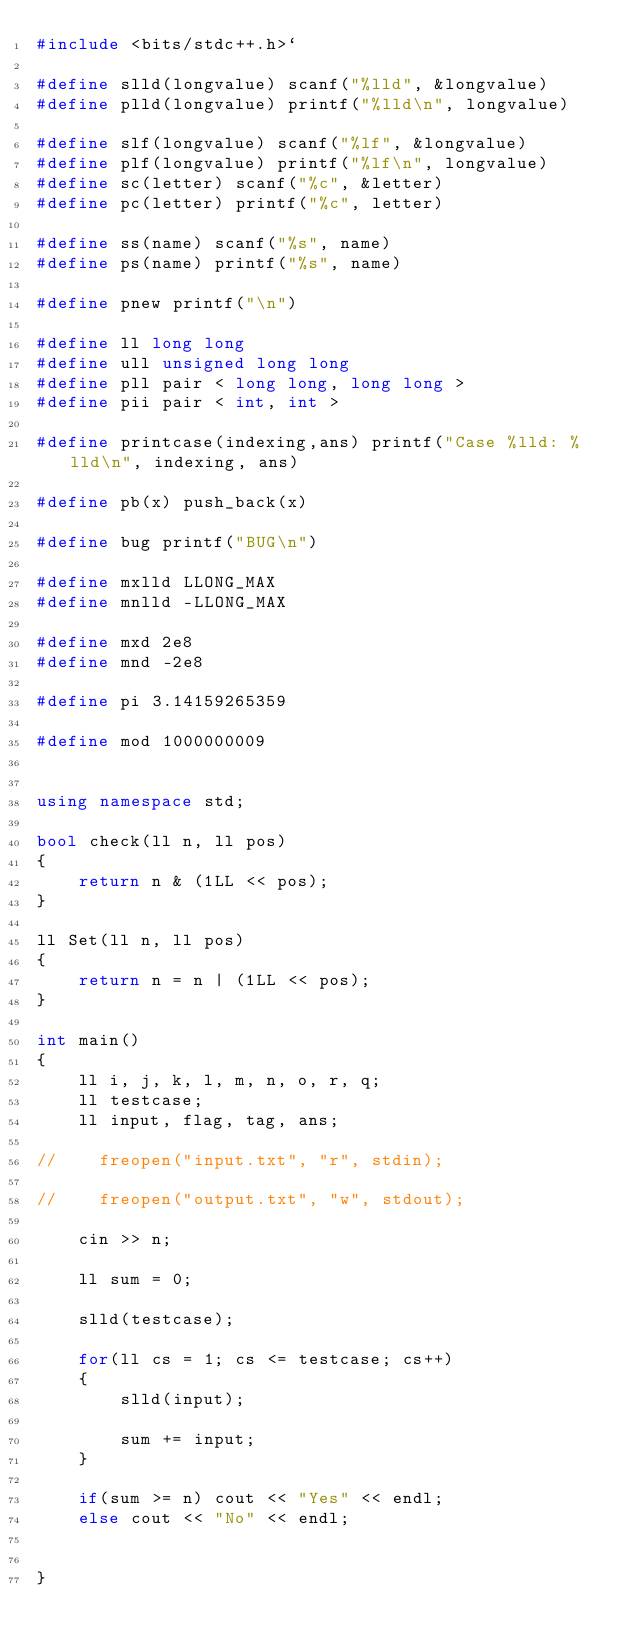Convert code to text. <code><loc_0><loc_0><loc_500><loc_500><_C++_>#include <bits/stdc++.h>`

#define slld(longvalue) scanf("%lld", &longvalue)
#define plld(longvalue) printf("%lld\n", longvalue)

#define slf(longvalue) scanf("%lf", &longvalue)
#define plf(longvalue) printf("%lf\n", longvalue)
#define sc(letter) scanf("%c", &letter)
#define pc(letter) printf("%c", letter)

#define ss(name) scanf("%s", name)
#define ps(name) printf("%s", name)

#define pnew printf("\n")

#define ll long long
#define ull unsigned long long
#define pll pair < long long, long long >
#define pii pair < int, int >

#define printcase(indexing,ans) printf("Case %lld: %lld\n", indexing, ans)

#define pb(x) push_back(x)

#define bug printf("BUG\n")

#define mxlld LLONG_MAX
#define mnlld -LLONG_MAX

#define mxd 2e8
#define mnd -2e8

#define pi 3.14159265359

#define mod 1000000009


using namespace std;

bool check(ll n, ll pos)
{
	return n & (1LL << pos);
}

ll Set(ll n, ll pos)
{
	return n = n | (1LL << pos);
}

int main()
{
    ll i, j, k, l, m, n, o, r, q;
    ll testcase;
    ll input, flag, tag, ans;

//    freopen("input.txt", "r", stdin);

//    freopen("output.txt", "w", stdout);

    cin >> n;

    ll sum = 0;

    slld(testcase);

    for(ll cs = 1; cs <= testcase; cs++)
    {
        slld(input);

        sum += input;
    }

    if(sum >= n) cout << "Yes" << endl;
    else cout << "No" << endl;


}


</code> 